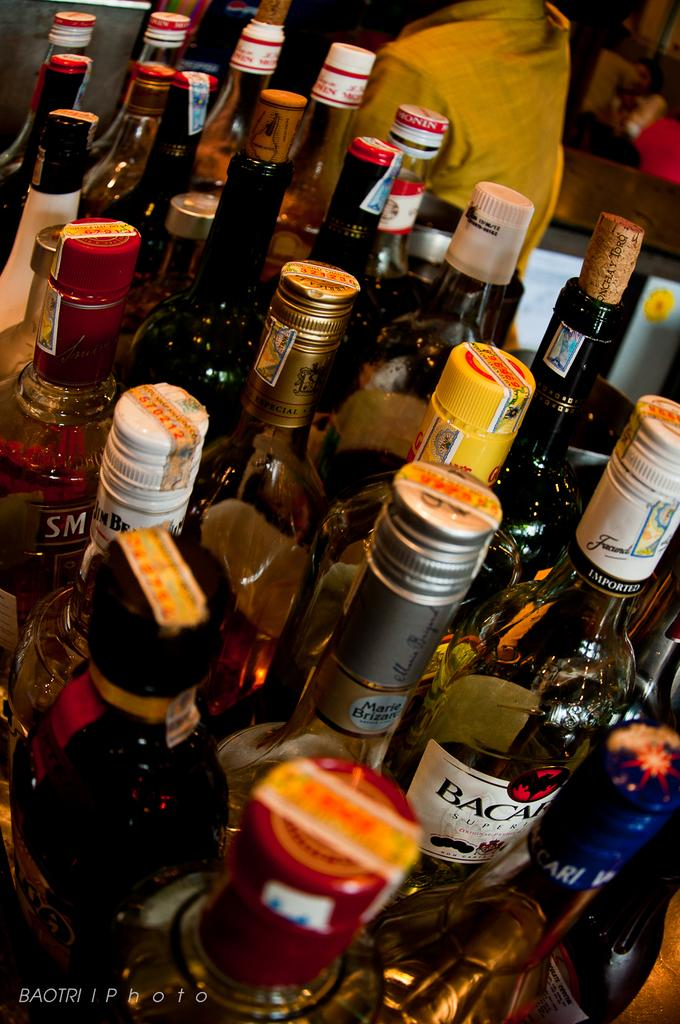<image>
Summarize the visual content of the image. many liquor bottles like Bacardi on a table 